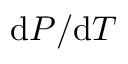<formula> <loc_0><loc_0><loc_500><loc_500>d P / d T</formula> 